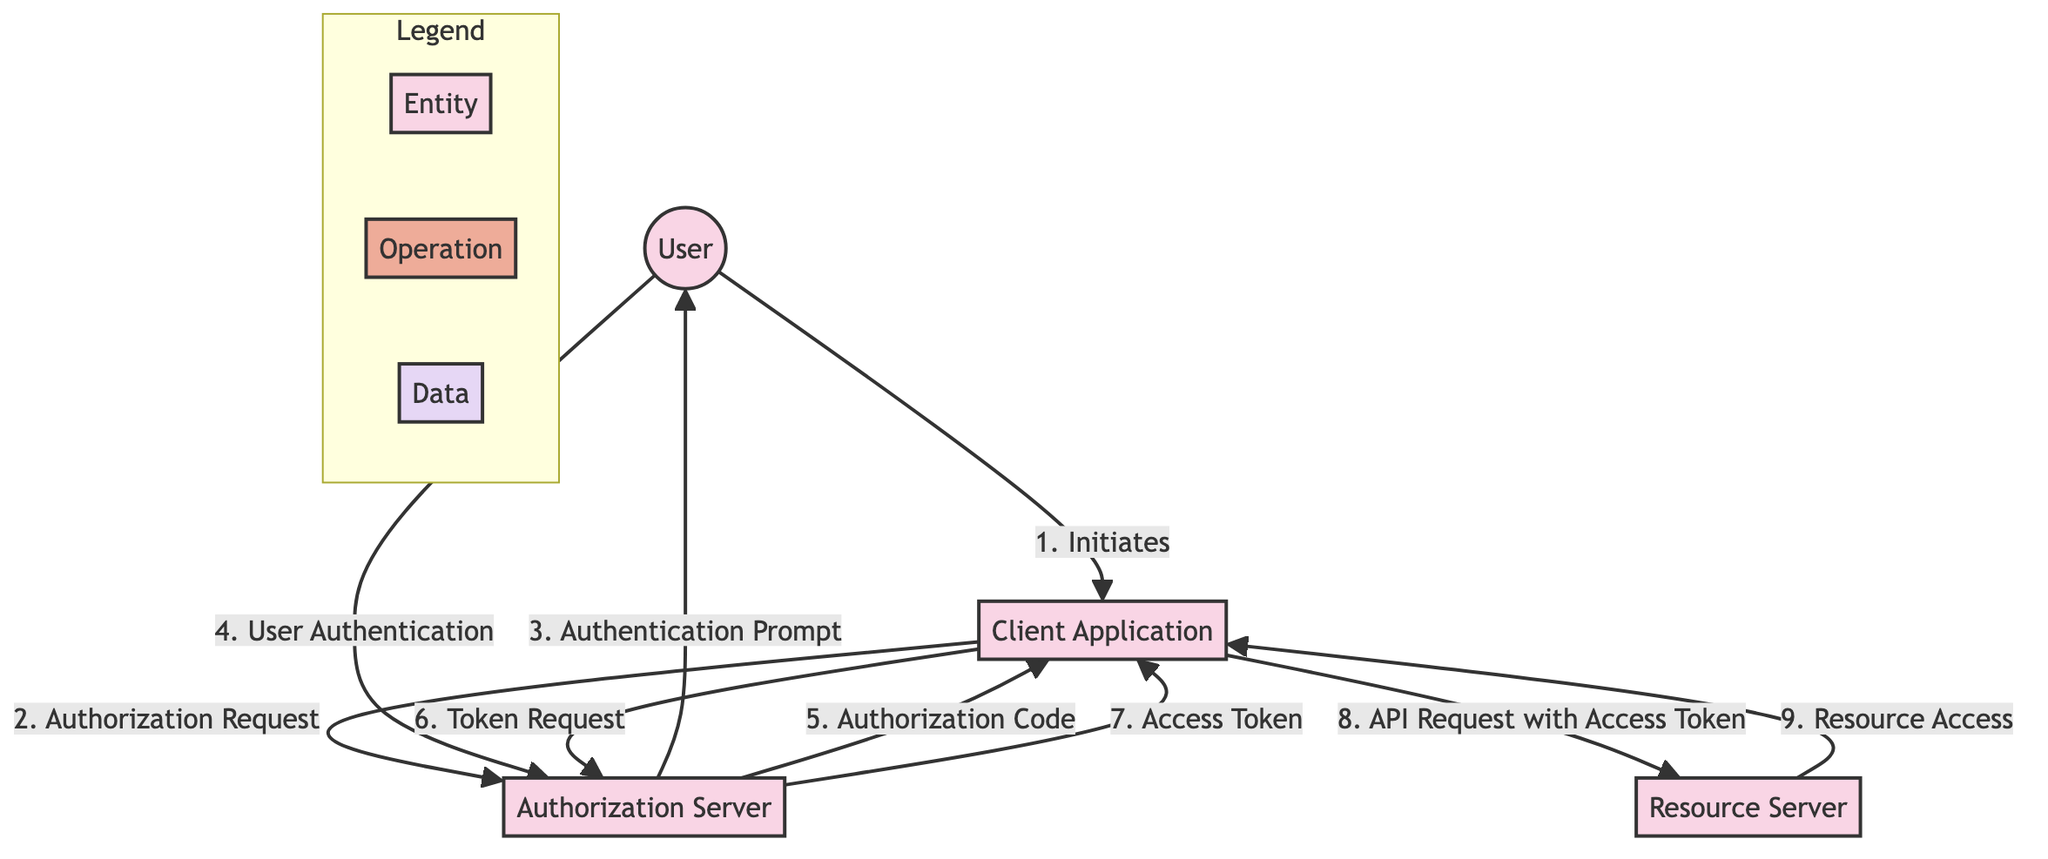What's the first step in the authentication flow? The first step in the authentication flow is initiated by the User who starts the process by interacting with the Client Application.
Answer: Initiates How many entities are present in the diagram? The diagram contains four entities: User, Client Application, Authorization Server, and Resource Server.
Answer: Four What does the Client Application send to the Authorization Server? The Client Application sends an Authorization Request to the Authorization Server to initiate the authentication process.
Answer: Authorization Request What is issued by the Authorization Server after successful user authentication? After the User successfully authenticates, the Authorization Server issues an Authorization Code to the Client Application.
Answer: Authorization Code What does the Client Application exchange for an Access Token? The Client Application exchanges the Authorization Code for an Access Token at the Authorization Server in the Token Request step.
Answer: Authorization Code What must the Resource Server do before providing requested resources? The Resource Server must validate the Access Token before providing access to the resources requested by the Client Application.
Answer: Validate the Access Token What number in the flow represents the API Request? The API Request is represented by the numeral 8 in the flow, indicating it is the eighth step in the process.
Answer: Eight Who provides the credentials for User Authentication? The User provides the necessary credentials to authenticate with the Authorization Server during the User Authentication step.
Answer: User What is the outcome after the Resource Access operation? The outcome after the Resource Access operation is that the Resource Server provides the requested resources back to the Client Application.
Answer: Provides the requested resources 